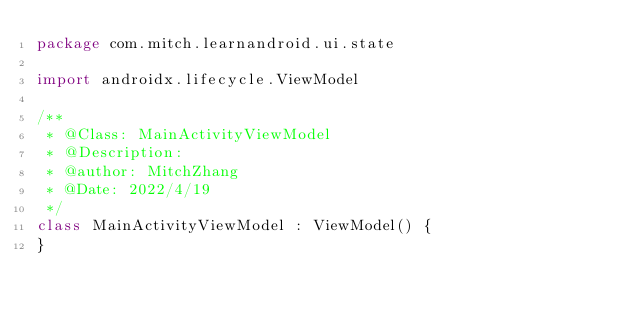<code> <loc_0><loc_0><loc_500><loc_500><_Kotlin_>package com.mitch.learnandroid.ui.state

import androidx.lifecycle.ViewModel

/**
 * @Class: MainActivityViewModel
 * @Description:
 * @author: MitchZhang
 * @Date: 2022/4/19
 */
class MainActivityViewModel : ViewModel() {
}</code> 